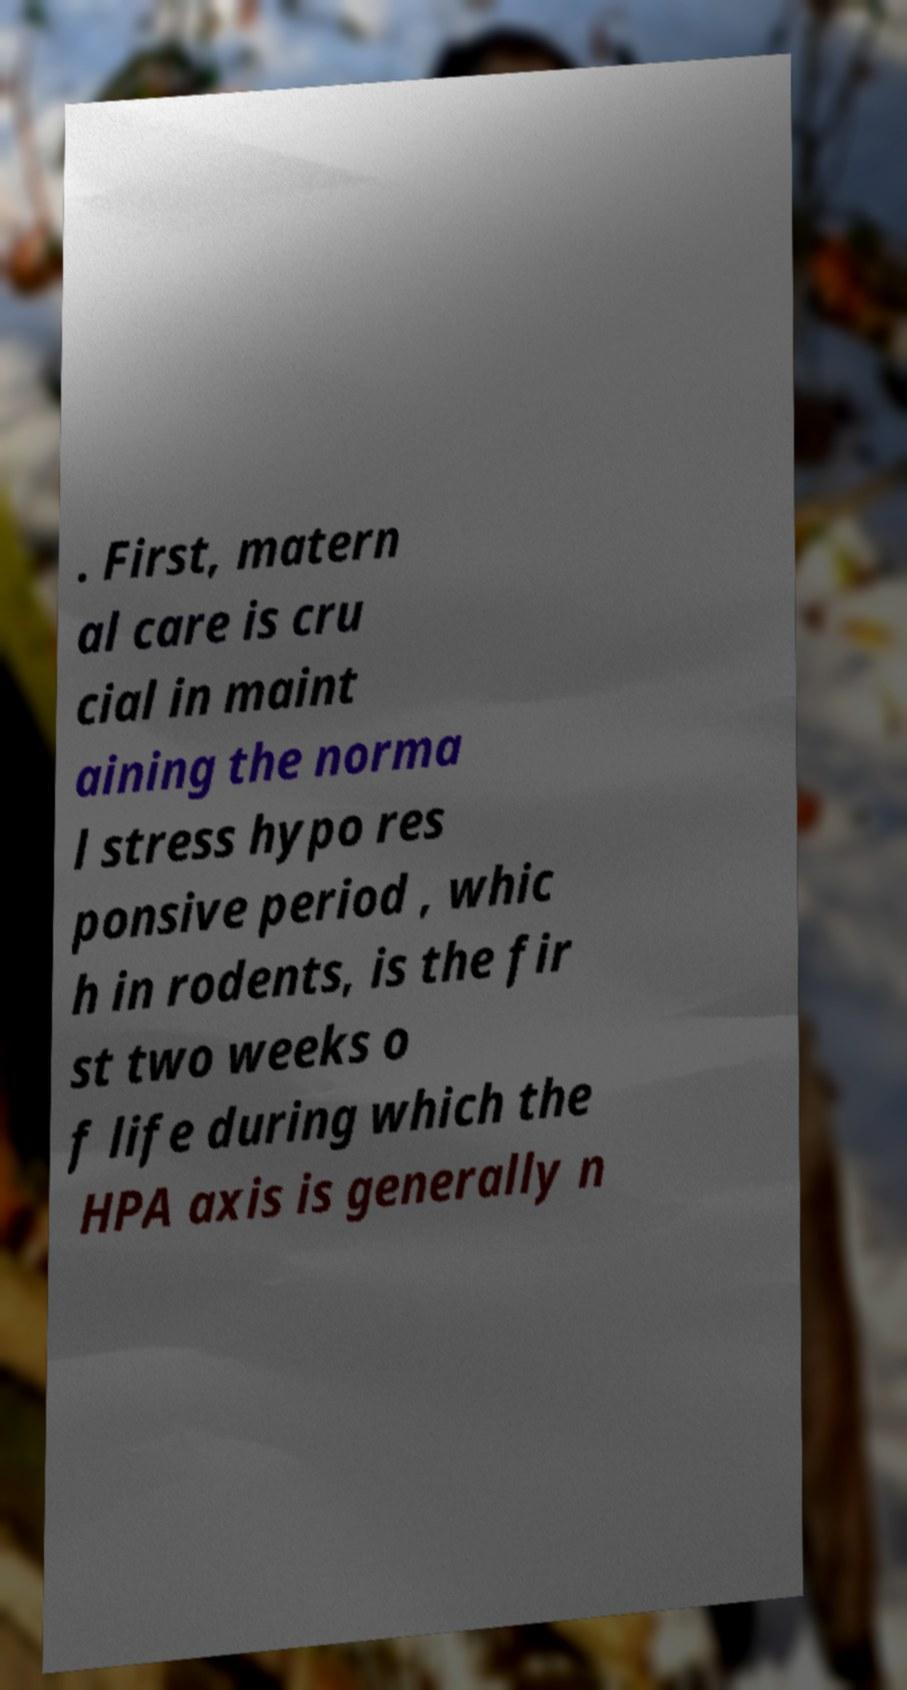Could you assist in decoding the text presented in this image and type it out clearly? . First, matern al care is cru cial in maint aining the norma l stress hypo res ponsive period , whic h in rodents, is the fir st two weeks o f life during which the HPA axis is generally n 